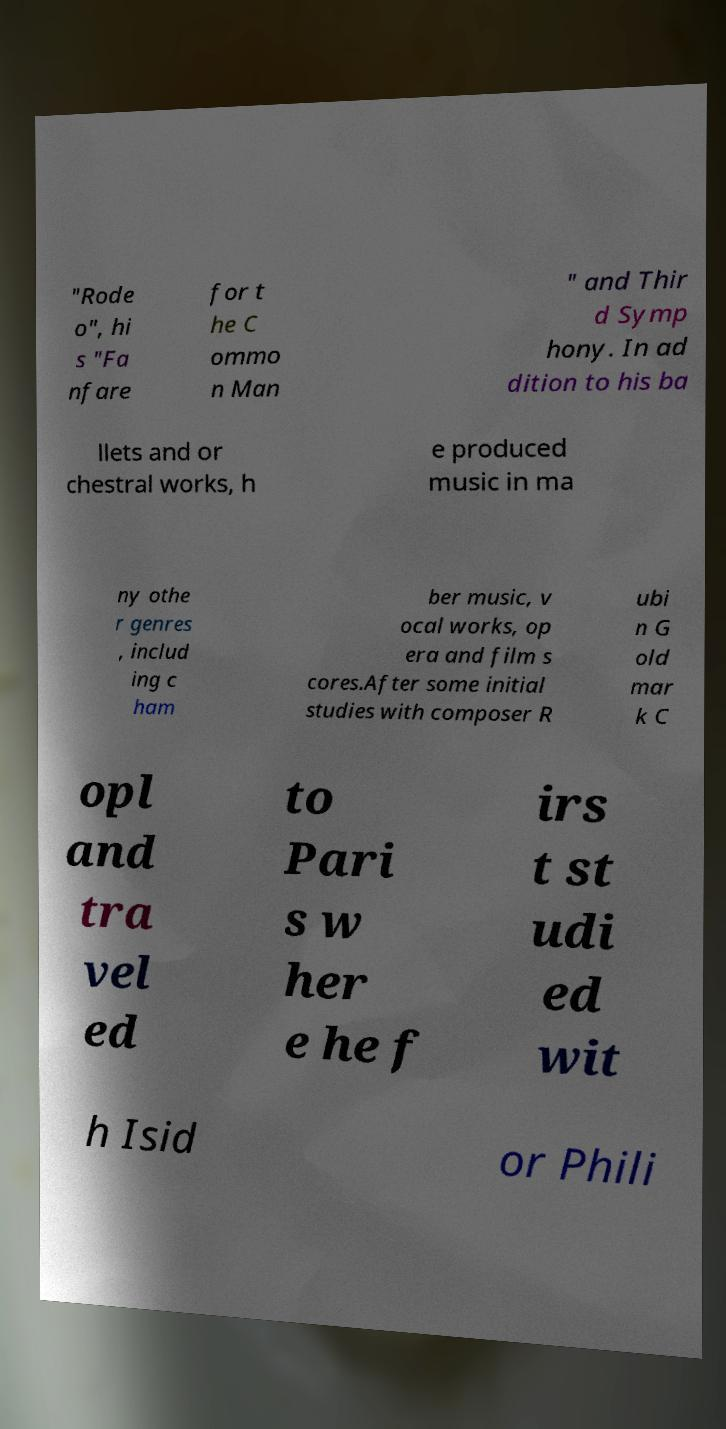Please read and relay the text visible in this image. What does it say? "Rode o", hi s "Fa nfare for t he C ommo n Man " and Thir d Symp hony. In ad dition to his ba llets and or chestral works, h e produced music in ma ny othe r genres , includ ing c ham ber music, v ocal works, op era and film s cores.After some initial studies with composer R ubi n G old mar k C opl and tra vel ed to Pari s w her e he f irs t st udi ed wit h Isid or Phili 